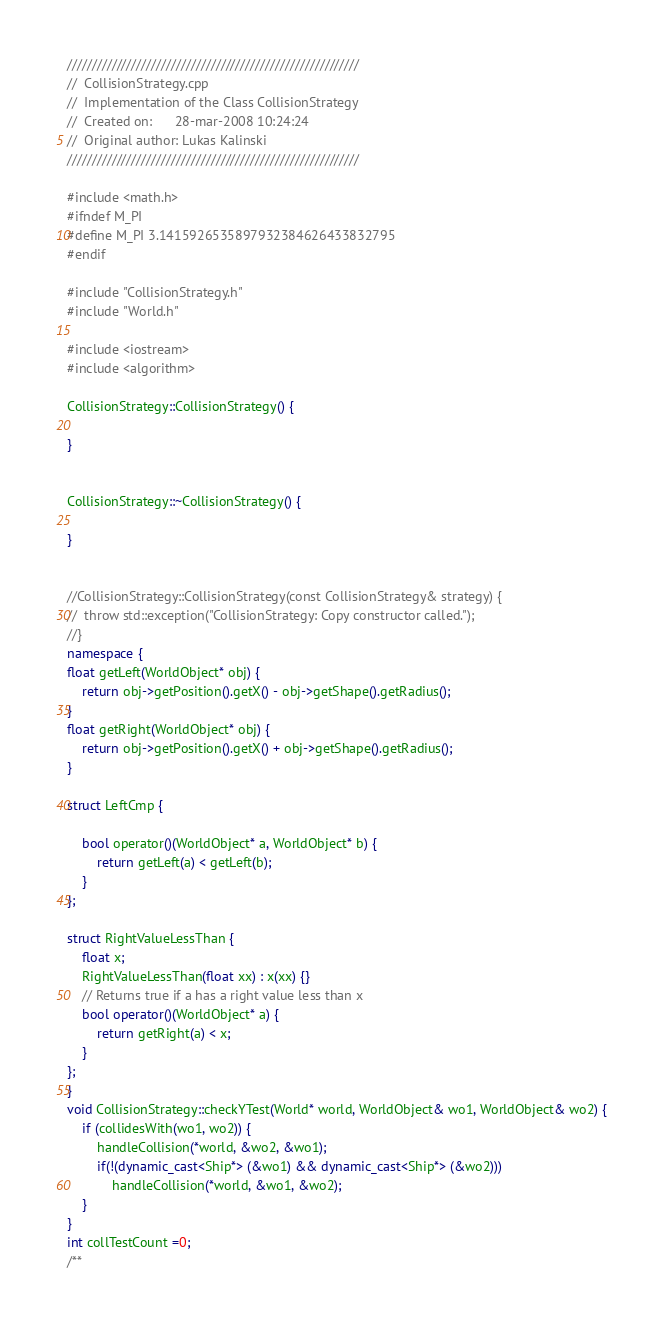<code> <loc_0><loc_0><loc_500><loc_500><_C++_>///////////////////////////////////////////////////////////
//  CollisionStrategy.cpp
//  Implementation of the Class CollisionStrategy
//  Created on:      28-mar-2008 10:24:24
//  Original author: Lukas Kalinski
///////////////////////////////////////////////////////////

#include <math.h>
#ifndef M_PI
#define M_PI 3.1415926535897932384626433832795
#endif

#include "CollisionStrategy.h"
#include "World.h"

#include <iostream>
#include <algorithm>

CollisionStrategy::CollisionStrategy() {

}


CollisionStrategy::~CollisionStrategy() {

}


//CollisionStrategy::CollisionStrategy(const CollisionStrategy& strategy) {
//	throw std::exception("CollisionStrategy: Copy constructor called.");
//}
namespace {
float getLeft(WorldObject* obj) {
	return obj->getPosition().getX() - obj->getShape().getRadius();
}
float getRight(WorldObject* obj) {
	return obj->getPosition().getX() + obj->getShape().getRadius();
}

struct LeftCmp {

	bool operator()(WorldObject* a, WorldObject* b) {
		return getLeft(a) < getLeft(b);
	}
};

struct RightValueLessThan {
	float x;
	RightValueLessThan(float xx) : x(xx) {}
	// Returns true if a has a right value less than x
	bool operator()(WorldObject* a) {
		return getRight(a) < x;
	}
};
}
void CollisionStrategy::checkYTest(World* world, WorldObject& wo1, WorldObject& wo2) {
	if (collidesWith(wo1, wo2)) {
		handleCollision(*world, &wo2, &wo1);
		if(!(dynamic_cast<Ship*> (&wo1) && dynamic_cast<Ship*> (&wo2)))
			handleCollision(*world, &wo1, &wo2);
	}
}
int collTestCount =0;
/**</code> 